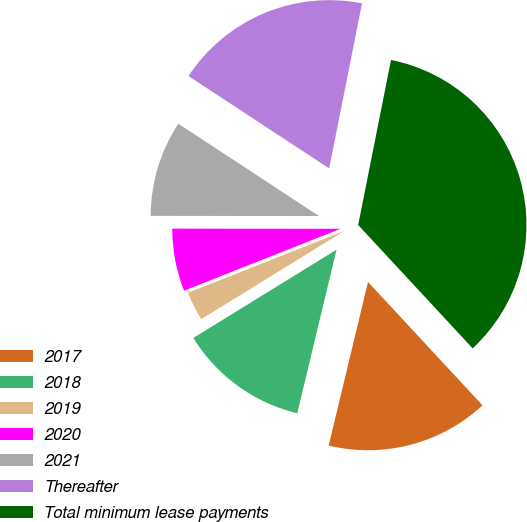Convert chart. <chart><loc_0><loc_0><loc_500><loc_500><pie_chart><fcel>2017<fcel>2018<fcel>2019<fcel>2020<fcel>2021<fcel>Thereafter<fcel>Total minimum lease payments<nl><fcel>15.66%<fcel>12.45%<fcel>2.8%<fcel>6.01%<fcel>9.23%<fcel>18.88%<fcel>34.97%<nl></chart> 